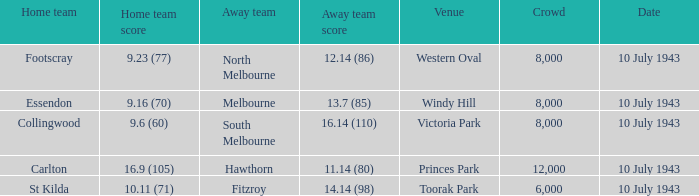At victoria park venue, what was the away team's score? 16.14 (110). 